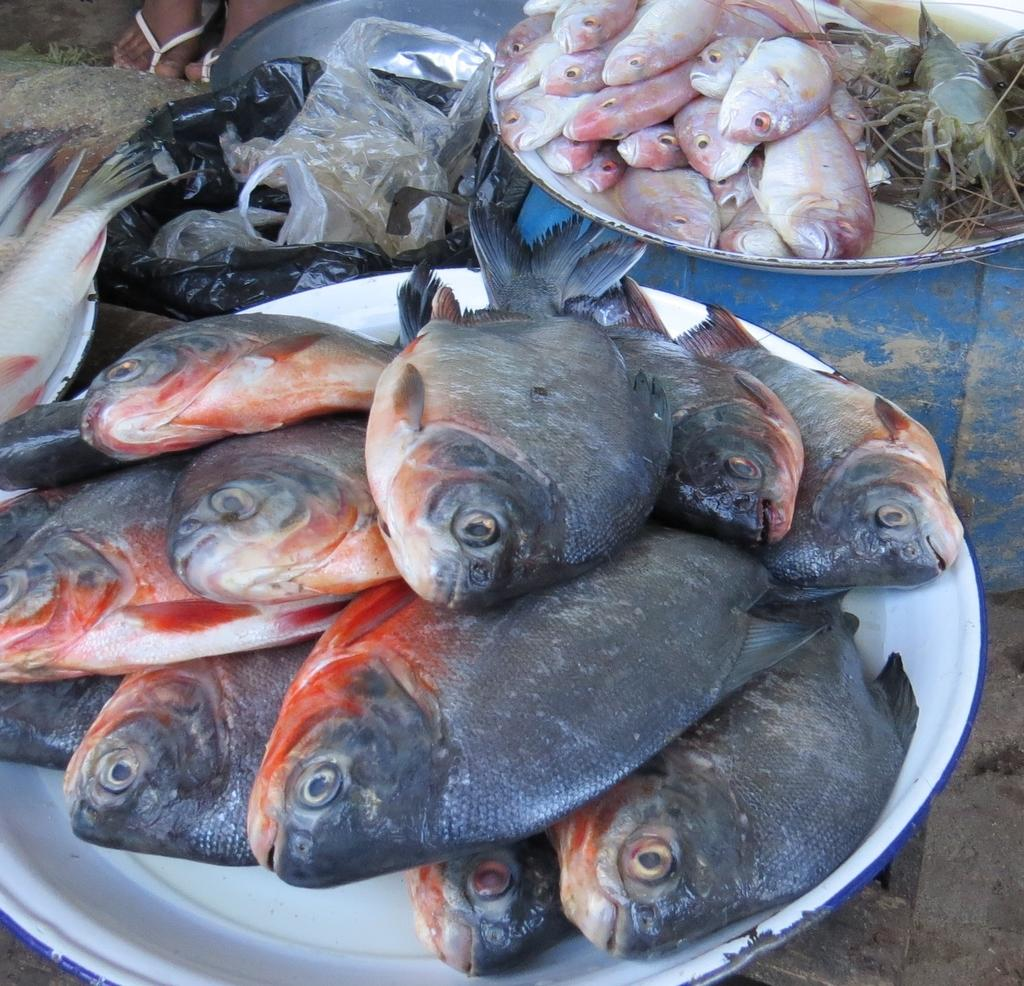What colors are the fishes in the image? There are black-colored and pink-colored fishes in the image. What other sea creatures can be seen in the image? There are crabs in the image. How are the crabs presented in the image? The crabs are in plates. Can you tell me how many hearts are visible in the image? There are no hearts visible in the image; it features fishes and crabs. What type of kitty can be seen interacting with the crabs in the image? There is no kitty present in the image; it only features fishes and crabs. 